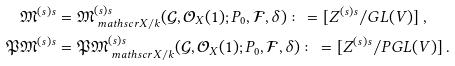Convert formula to latex. <formula><loc_0><loc_0><loc_500><loc_500>\mathfrak { M } ^ { ( s ) s } & = \mathfrak { M } ^ { ( s ) s } _ { \ m a t h s c r { X } / k } ( \mathcal { G } , \mathcal { O } _ { X } ( 1 ) ; P _ { 0 } , \mathcal { F } , \delta ) \colon = [ Z ^ { ( s ) s } / G L ( V ) ] \ , \\ \mathfrak { P M } ^ { ( s ) s } & = \mathfrak { P M } ^ { ( s ) s } _ { \ m a t h s c r { X } / k } ( \mathcal { G } , \mathcal { O } _ { X } ( 1 ) ; P _ { 0 } , \mathcal { F } , \delta ) \colon = [ Z ^ { ( s ) s } / P G L ( V ) ] \ .</formula> 